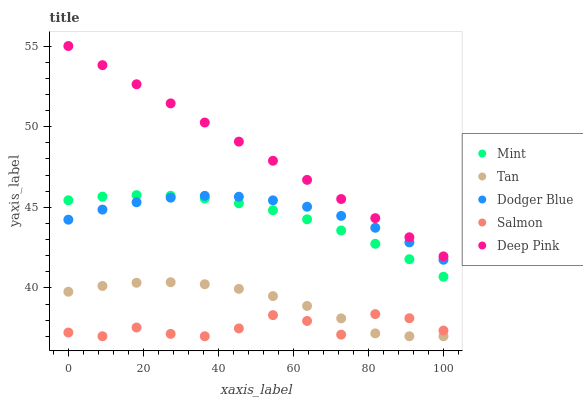Does Salmon have the minimum area under the curve?
Answer yes or no. Yes. Does Deep Pink have the maximum area under the curve?
Answer yes or no. Yes. Does Tan have the minimum area under the curve?
Answer yes or no. No. Does Tan have the maximum area under the curve?
Answer yes or no. No. Is Deep Pink the smoothest?
Answer yes or no. Yes. Is Salmon the roughest?
Answer yes or no. Yes. Is Tan the smoothest?
Answer yes or no. No. Is Tan the roughest?
Answer yes or no. No. Does Tan have the lowest value?
Answer yes or no. Yes. Does Deep Pink have the lowest value?
Answer yes or no. No. Does Deep Pink have the highest value?
Answer yes or no. Yes. Does Tan have the highest value?
Answer yes or no. No. Is Mint less than Deep Pink?
Answer yes or no. Yes. Is Deep Pink greater than Mint?
Answer yes or no. Yes. Does Salmon intersect Tan?
Answer yes or no. Yes. Is Salmon less than Tan?
Answer yes or no. No. Is Salmon greater than Tan?
Answer yes or no. No. Does Mint intersect Deep Pink?
Answer yes or no. No. 